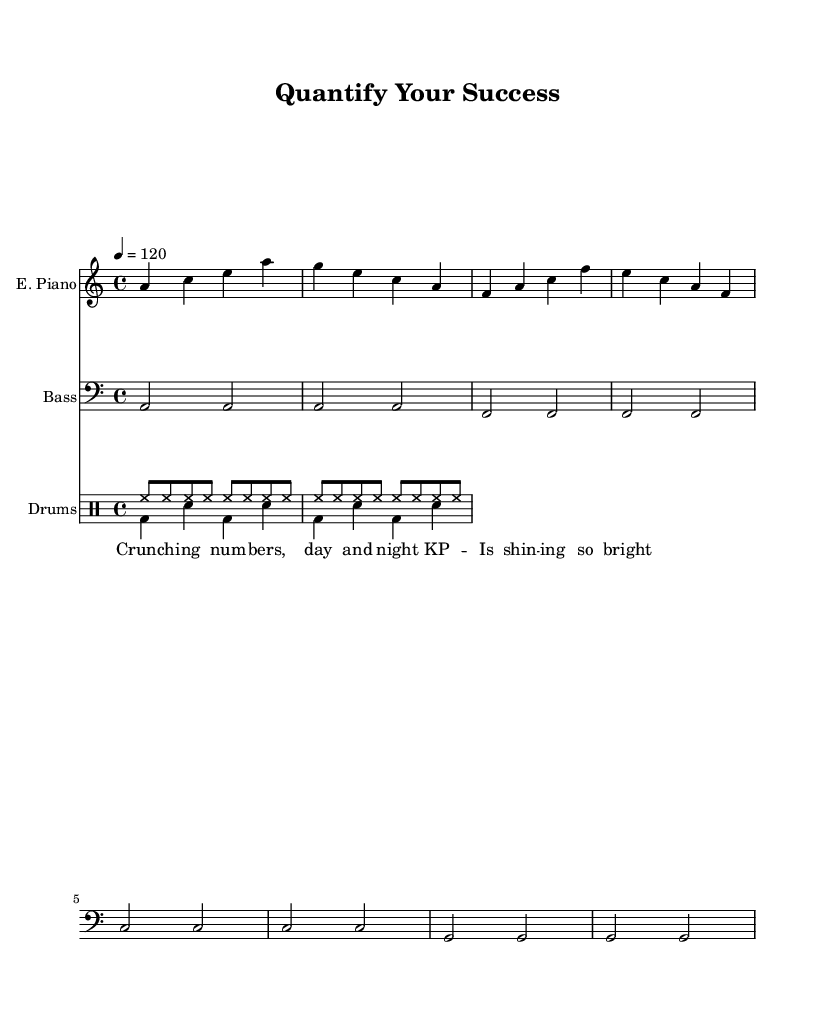What is the key signature of this music? The key signature is a minor, which contains no sharps or flats.
Answer: A minor What is the time signature for this piece? The time signature shown indicates that there are four beats in each measure, which is represented as 4/4.
Answer: 4/4 What is the tempo marking for this music? The tempo marking states that the quarter note gets a value of 120 beats per minute, which signifies a moderately fast pace.
Answer: 120 How many measures does the electric piano part have? There are four measures in the electric piano part, as indicated in the notation, which consists of four separate groups.
Answer: Four measures What instruments are used in this piece? The sheet music illustrates that the instrumentation includes electric piano, bass guitar, and drums.
Answer: Electric piano, bass guitar, drums What lyric theme is presented in this song? The lyrics focus on quantifiable success and performance metrics, referencing the act of "crunching numbers" and the brightness of KPIs.
Answer: Quantifiable success Why might the bass guitar use half notes here? The use of half notes in the bass guitar part allows for a steady, foundational pulse, typical in disco music that emphasizes rhythm and groove, providing a strong support for the upbeat feel.
Answer: Steady rhythm 